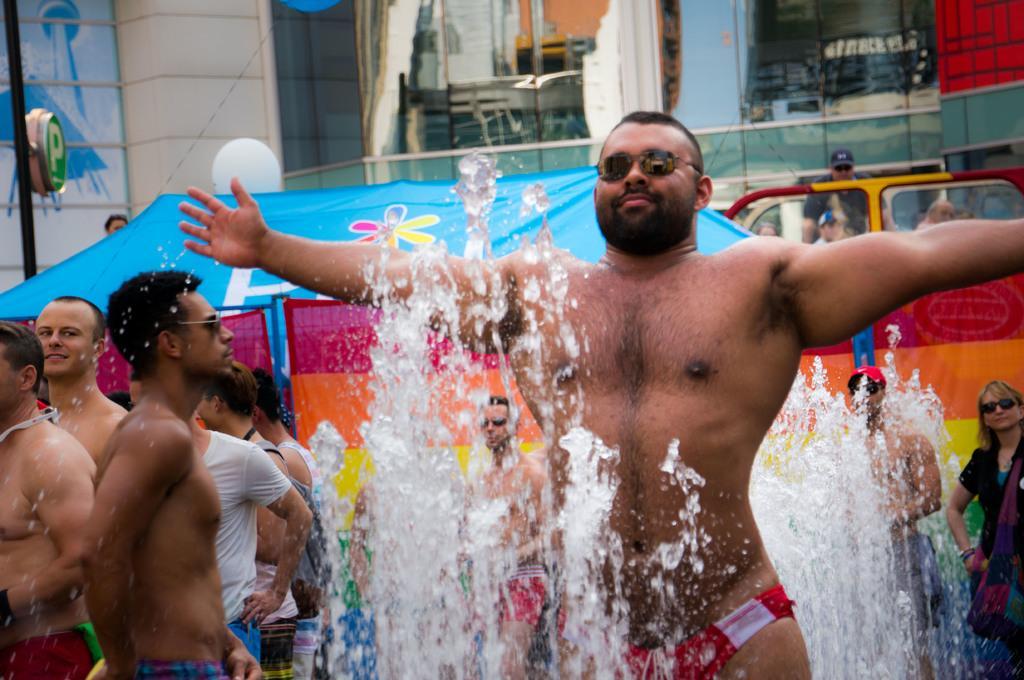Could you give a brief overview of what you see in this image? In this picture we can observe a person standing, wearing spectacles. There is a fountain in front of him. We can observe some people standing. In the background we can observe a blue color tint and a black color pole on the left side. We can observe a building here. 